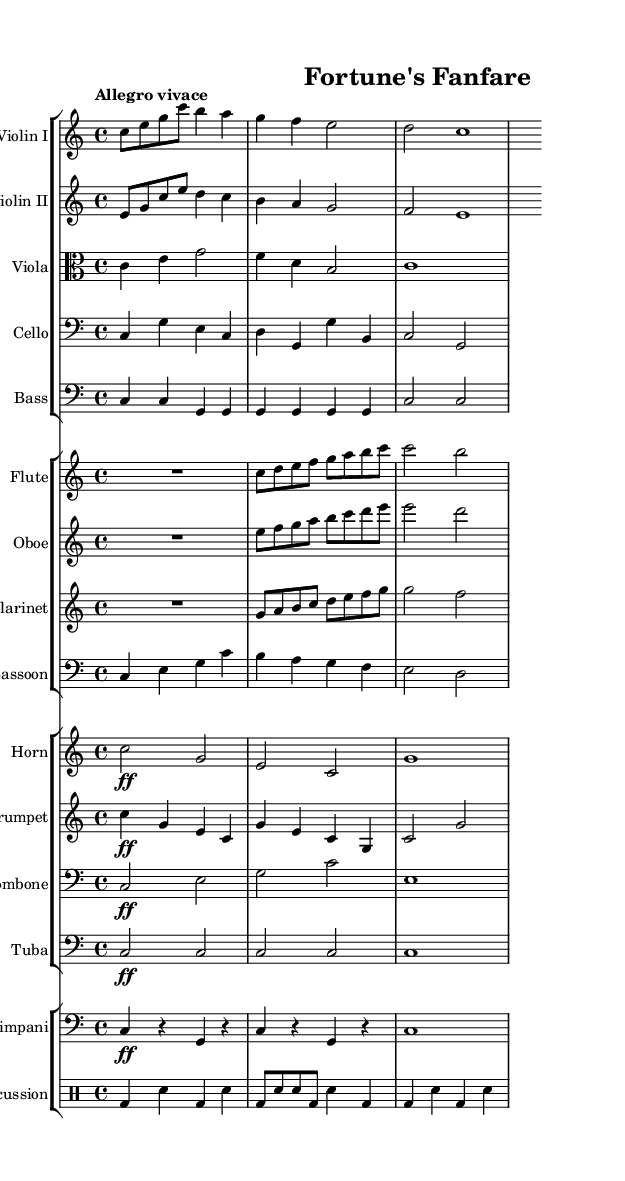What is the key signature of this music? The key signature is C major, which has no sharps or flats.
Answer: C major What is the time signature of this symphony? The time signature shown is 4/4, indicating four beats per measure.
Answer: 4/4 What is the tempo marking for this piece? The tempo marking at the beginning indicates "Allegro vivace," which means fast and lively.
Answer: Allegro vivace How many instrument groups are in this score? The score consists of four distinct instrument groups: strings, woodwinds, brass, and percussion.
Answer: Four Which instrument plays the opening melody? The opening melody is played by the first violin, as seen in the first staff.
Answer: Violin I Identify the dynamic marking for the horn. The dynamic marking for the horn is "forte," indicated by the symbol "ff."
Answer: Forte What is the rhythmic pattern in the percussion part? The percussion part primarily alternates between bass drum and snare hits in a rhythmic pattern.
Answer: BD, SN 